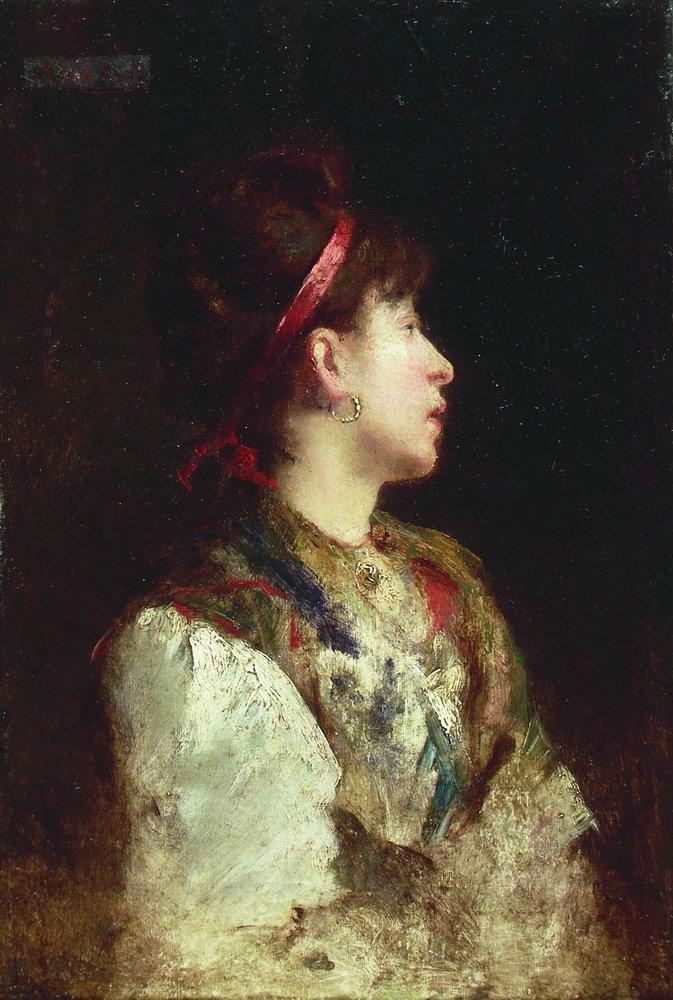Describe the following image. The image portrays a profile of a young woman painted in an impressionistic style. The artist has used loose brushstrokes, capturing a sense of movement and life. The light and shadow play bring depth and dimension, highlighting the subject against a dark, indistinct background.

The woman, facing to the right, wears a red headband that contrasts with her dark hair. She is dressed in a white blouse, and over it, a colorful shawl adds vibrant splashes to the muted tones of her attire. A gold earring dangles from her ear, complemented by a necklace that adorns her neck.

The background's darkness accentuates the woman’s face and upper body, drawing the viewer's attention to her. The composition and color use evoke a thoughtful and introspective mood, giving insight into the subject's inner world through the impressionist technique. 